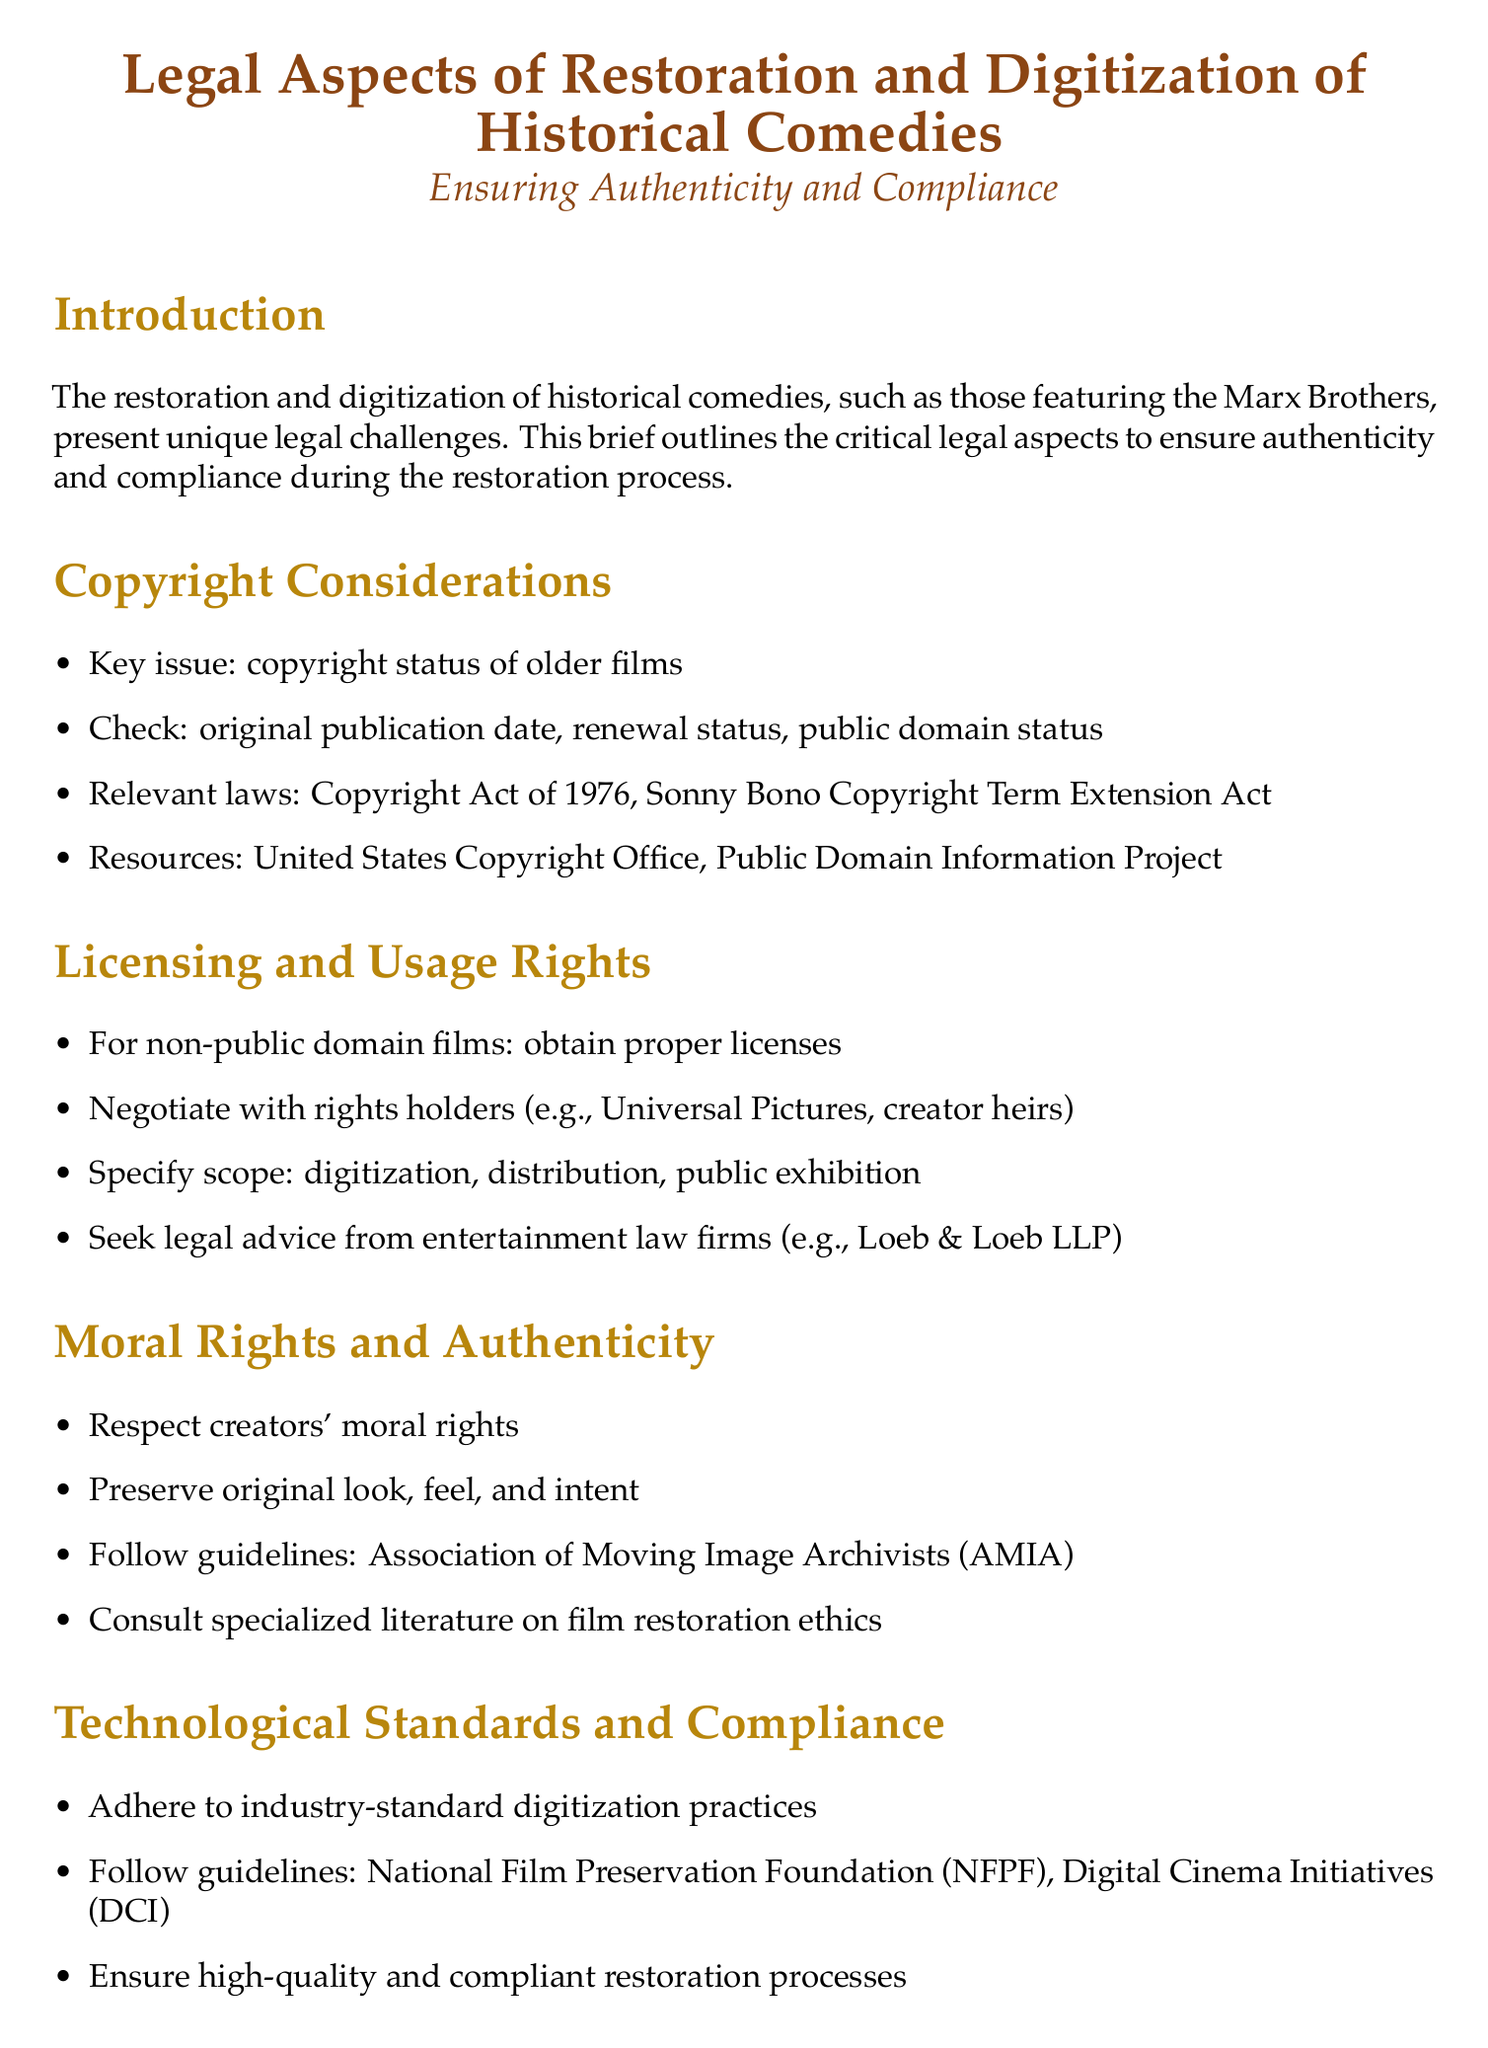What is the key issue in copyright considerations? The document states that the key issue is the copyright status of older films.
Answer: copyright status of older films Which Act extends copyright terms? The Sonny Bono Copyright Term Extension Act is mentioned as relevant to copyright laws.
Answer: Sonny Bono Copyright Term Extension Act What is required for non-public domain films? The document specifies that for non-public domain films, proper licenses must be obtained.
Answer: obtain proper licenses Who should be consulted for film restoration ethics? The document advises consulting specialized literature on film restoration ethics.
Answer: specialized literature on film restoration ethics What standards should be followed in digitization practices? The digitization practices should adhere to industry-standard guidelines provided by the National Film Preservation Foundation.
Answer: National Film Preservation Foundation What legislative compliance is addressed in data protection? The document refers to compliance with relevant legislation, specifically GDPR where applicable.
Answer: GDPR What rights should be respected during the restoration process? The document emphasizes the importance of respecting creators' moral rights in the restoration process.
Answer: creators' moral rights What is essential for preserving comedic legacy? The conclusion states that meticulous legal planning is essential for preserving the comedic legacy.
Answer: meticulous legal planning 